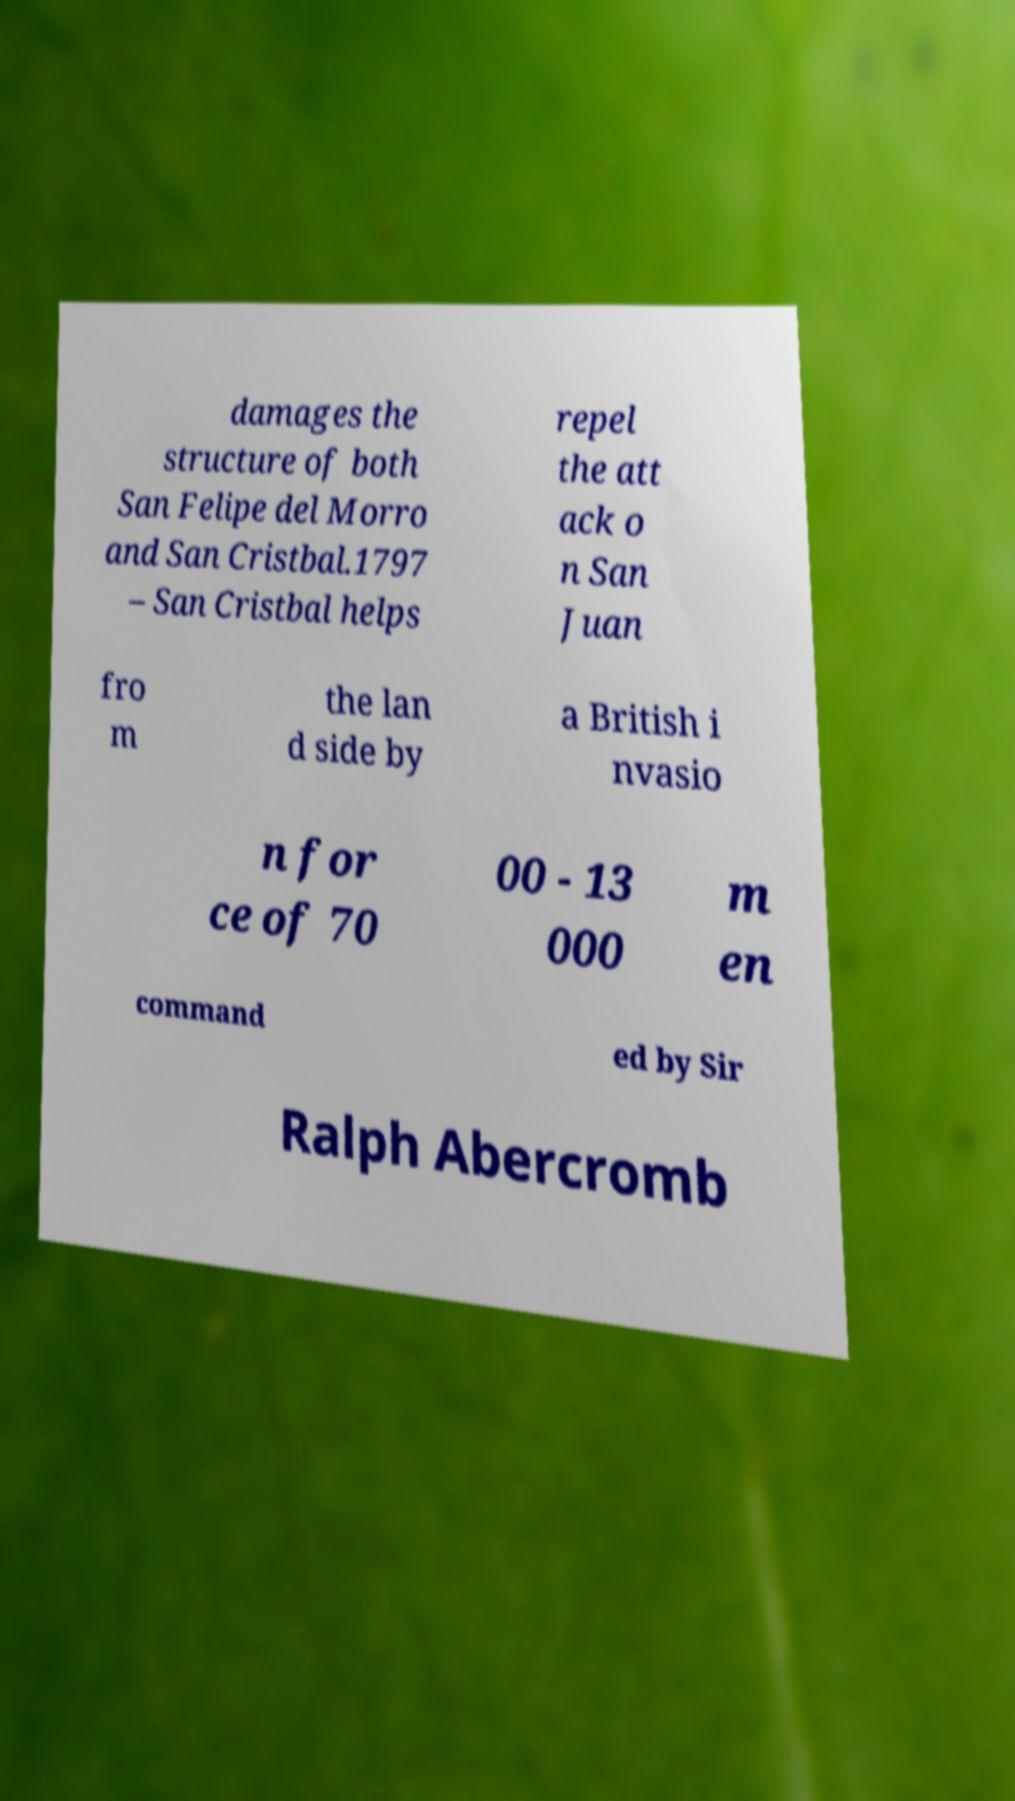Can you read and provide the text displayed in the image?This photo seems to have some interesting text. Can you extract and type it out for me? damages the structure of both San Felipe del Morro and San Cristbal.1797 – San Cristbal helps repel the att ack o n San Juan fro m the lan d side by a British i nvasio n for ce of 70 00 - 13 000 m en command ed by Sir Ralph Abercromb 